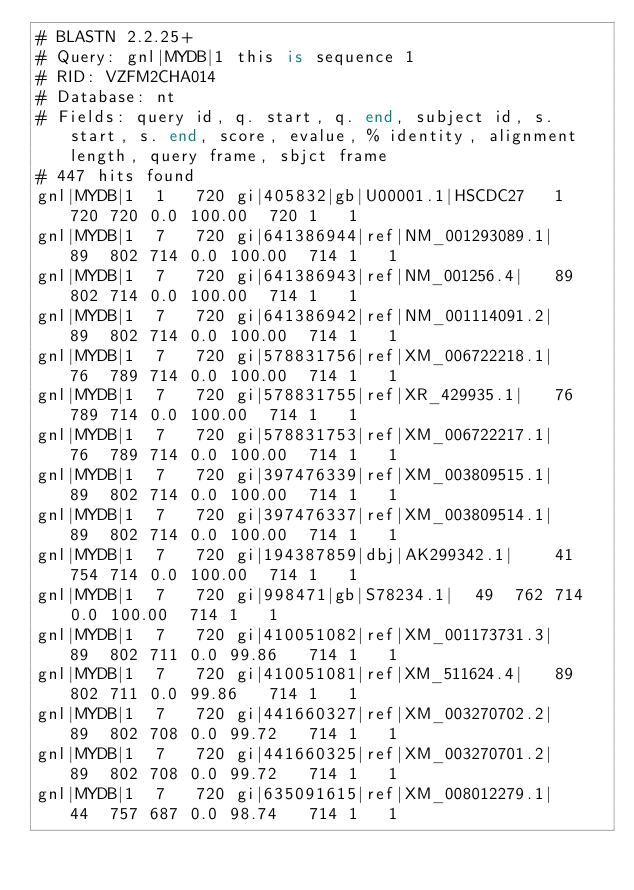Convert code to text. <code><loc_0><loc_0><loc_500><loc_500><_SQL_># BLASTN 2.2.25+
# Query: gnl|MYDB|1 this is sequence 1
# RID: VZFM2CHA014
# Database: nt
# Fields: query id, q. start, q. end, subject id, s. start, s. end, score, evalue, % identity, alignment length, query frame, sbjct frame
# 447 hits found
gnl|MYDB|1	1	720	gi|405832|gb|U00001.1|HSCDC27	1	720	720	0.0	100.00	720	1	1
gnl|MYDB|1	7	720	gi|641386944|ref|NM_001293089.1|	89	802	714	0.0	100.00	714	1	1
gnl|MYDB|1	7	720	gi|641386943|ref|NM_001256.4|	89	802	714	0.0	100.00	714	1	1
gnl|MYDB|1	7	720	gi|641386942|ref|NM_001114091.2|	89	802	714	0.0	100.00	714	1	1
gnl|MYDB|1	7	720	gi|578831756|ref|XM_006722218.1|	76	789	714	0.0	100.00	714	1	1
gnl|MYDB|1	7	720	gi|578831755|ref|XR_429935.1|	76	789	714	0.0	100.00	714	1	1
gnl|MYDB|1	7	720	gi|578831753|ref|XM_006722217.1|	76	789	714	0.0	100.00	714	1	1
gnl|MYDB|1	7	720	gi|397476339|ref|XM_003809515.1|	89	802	714	0.0	100.00	714	1	1
gnl|MYDB|1	7	720	gi|397476337|ref|XM_003809514.1|	89	802	714	0.0	100.00	714	1	1
gnl|MYDB|1	7	720	gi|194387859|dbj|AK299342.1|	41	754	714	0.0	100.00	714	1	1
gnl|MYDB|1	7	720	gi|998471|gb|S78234.1|	49	762	714	0.0	100.00	714	1	1
gnl|MYDB|1	7	720	gi|410051082|ref|XM_001173731.3|	89	802	711	0.0	99.86	714	1	1
gnl|MYDB|1	7	720	gi|410051081|ref|XM_511624.4|	89	802	711	0.0	99.86	714	1	1
gnl|MYDB|1	7	720	gi|441660327|ref|XM_003270702.2|	89	802	708	0.0	99.72	714	1	1
gnl|MYDB|1	7	720	gi|441660325|ref|XM_003270701.2|	89	802	708	0.0	99.72	714	1	1
gnl|MYDB|1	7	720	gi|635091615|ref|XM_008012279.1|	44	757	687	0.0	98.74	714	1	1</code> 